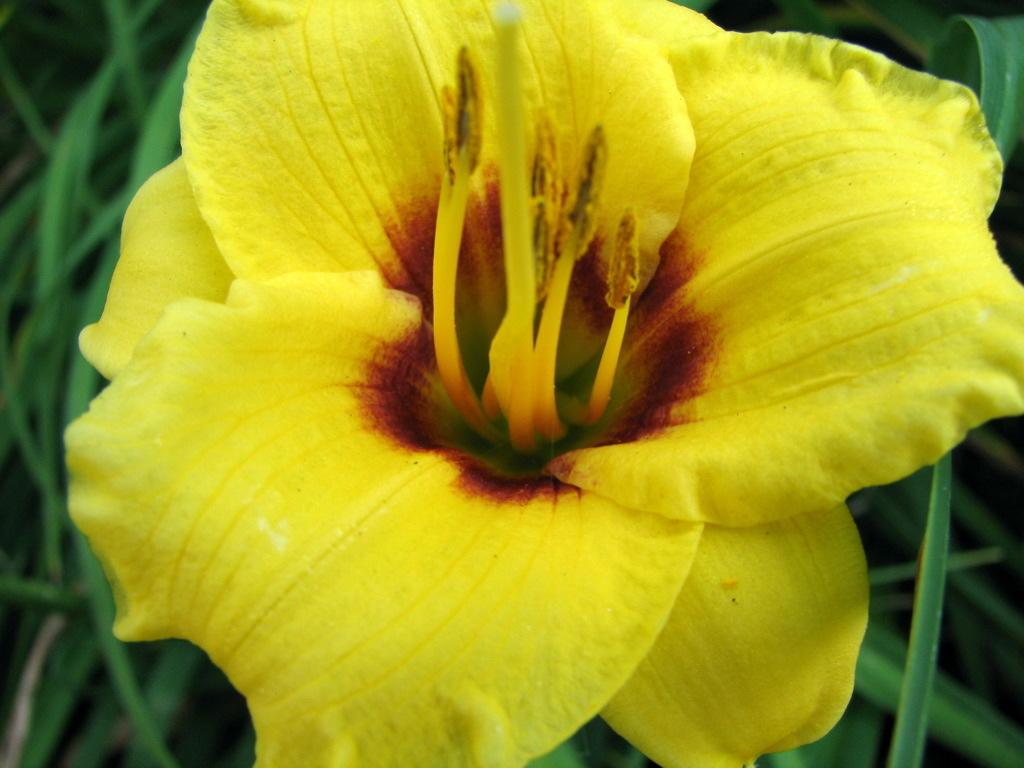What type of flower is in the image? There is a yellow flower in the image. What can be found in the center of the flower? The flower has stamens in the middle. What type of vegetation is visible behind the flower? There are grass plants visible behind the flower. What type of shoes can be seen on the twig in the image? There is no twig or shoes present in the image; it features a yellow flower with stamens and grass plants in the background. 